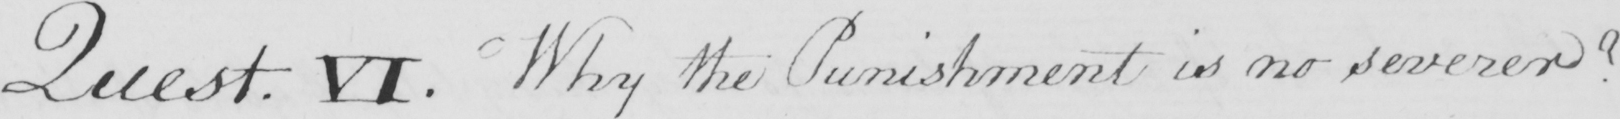Please transcribe the handwritten text in this image. Quest . VI . Why the Punishment is no severer ? 